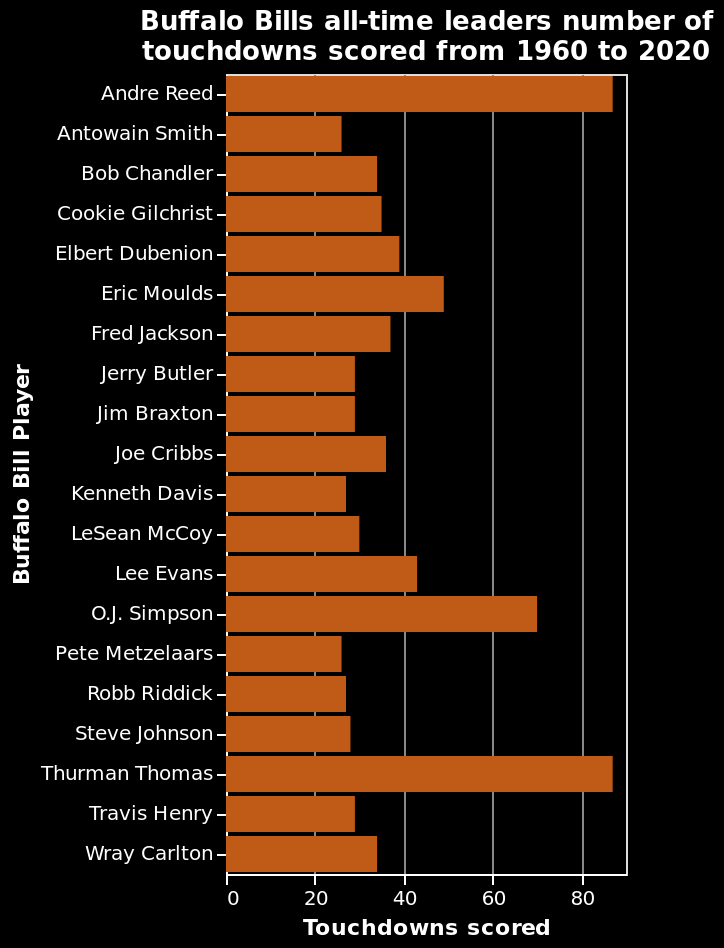<image>
Who is represented on the y-axis of the bar plot?  The y-axis of the bar plot represents Buffalo Bill Players. Are Thurman Thomas and Andre Reed still playing for the Buffalo Bills? No, they are retired players. How many touchdowns did Thurman Thomas and Andre Reed score for the Buffalo Bills?  The number of touchdowns they scored is not mentioned in the description. 